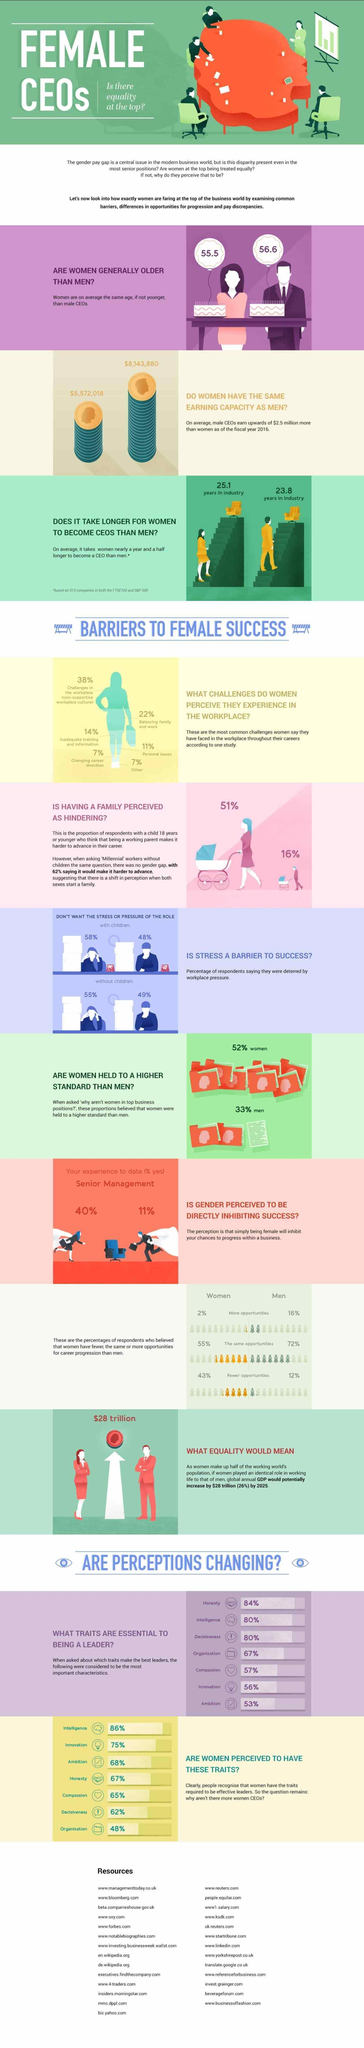How much do female CEOs earn on a average
Answer the question with a short phrase. $5,572,018 What is the average age of women CEOs 55.5 How many females without children dont want the stress or pressure of the role 55% How much do male CEOs earn on a average $8,143,880 How long does it take for males in industry to reach the position of a CEO 23.8 years How many males with children dont want the stress or pressure of the role 48% How long does it take for females in industry to reach the position of a CEO 25.1 years what is the average age of men CEOs 56.6 How many traits have been identified as essential to being a leader 7 